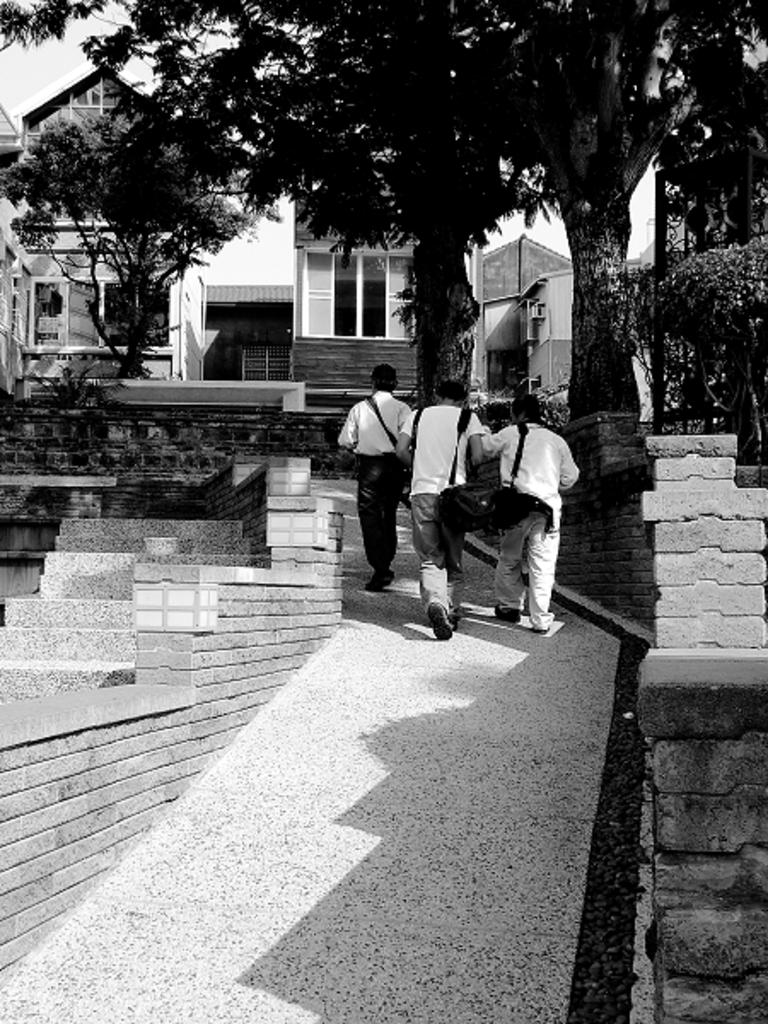How many people are in the image? There are three people in the image. What are the people doing in the image? The people are walking in the image. What are the people carrying while walking? The people are carrying bags in the image. What can be seen in the background of the image? There are buildings, trees, steps, and plants in the background of the image. What is the color scheme of the image? The image is black and white in color. What type of news can be heard coming from the rail in the image? There is no rail or news present in the image; it features three people walking while carrying bags. What type of sheet is covering the plants in the image? There is no sheet covering the plants in the image; the plants are visible in the background. 